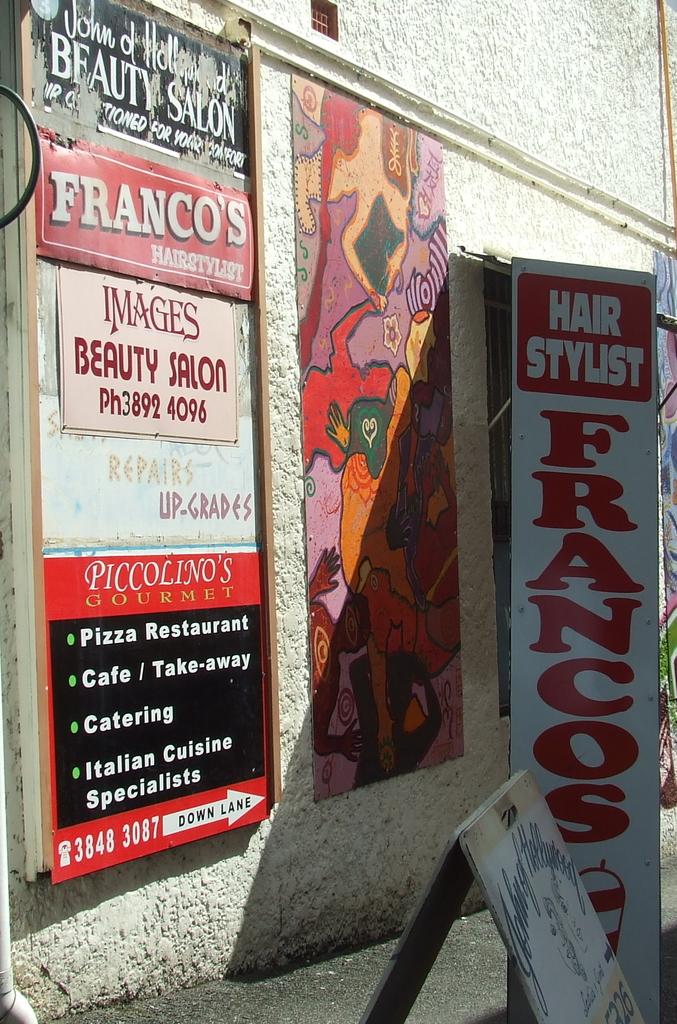What is the phone number to images beauty salon?
Give a very brief answer. 3892 4096. What is the name of the salon?
Your response must be concise. Francos. 